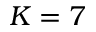<formula> <loc_0><loc_0><loc_500><loc_500>K = 7</formula> 